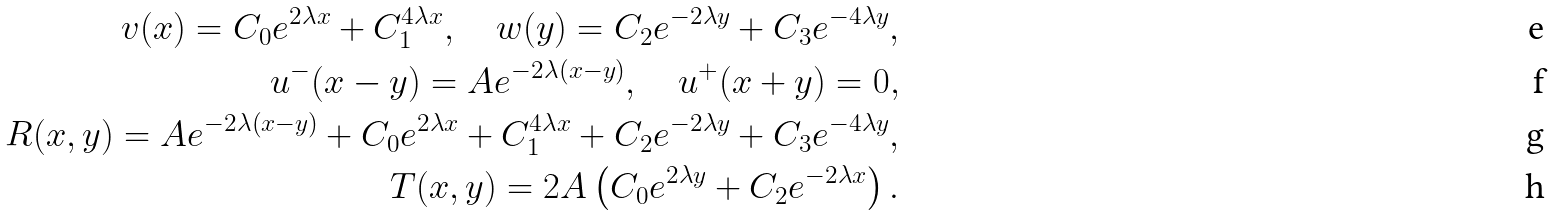Convert formula to latex. <formula><loc_0><loc_0><loc_500><loc_500>v ( x ) = C _ { 0 } e ^ { 2 \lambda x } + C _ { 1 } ^ { 4 \lambda x } , \quad w ( y ) = C _ { 2 } e ^ { - 2 \lambda y } + C _ { 3 } e ^ { - 4 \lambda y } , \\ u ^ { - } ( x - y ) = A e ^ { - 2 \lambda ( x - y ) } , \quad u ^ { + } ( x + y ) = 0 , \\ R ( x , y ) = A e ^ { - 2 \lambda ( x - y ) } + C _ { 0 } e ^ { 2 \lambda x } + C _ { 1 } ^ { 4 \lambda x } + C _ { 2 } e ^ { - 2 \lambda y } + C _ { 3 } e ^ { - 4 \lambda y } , \\ T ( x , y ) = 2 A \left ( C _ { 0 } e ^ { 2 \lambda y } + C _ { 2 } e ^ { - 2 \lambda x } \right ) .</formula> 